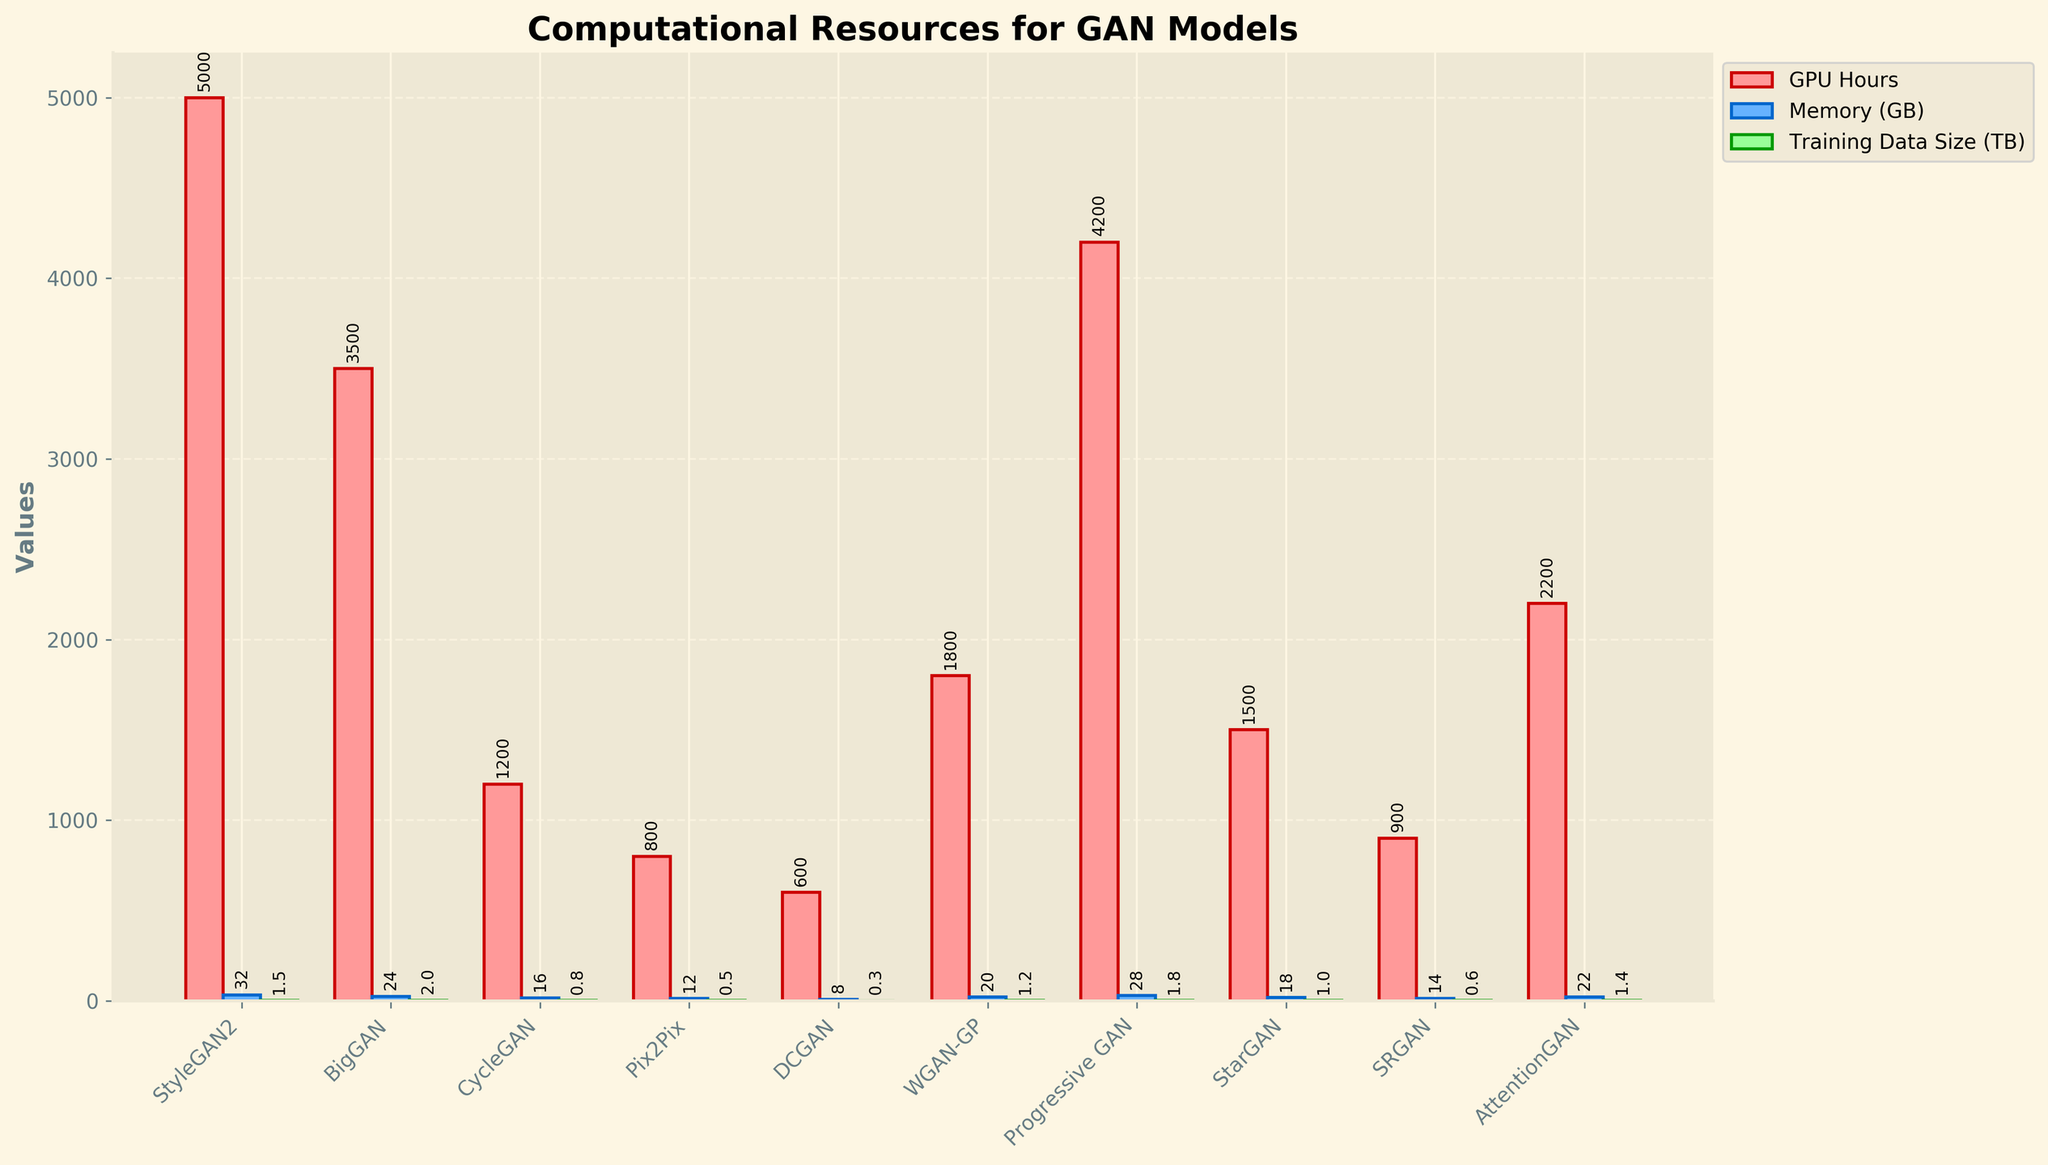Which GAN model requires the most GPU hours for training? The height of the red bar for each model indicates GPU hours. The tallest red bar corresponds to StyleGAN2.
Answer: StyleGAN2 Which GAN model uses the least memory (GB)? The height of the blue bar for each model indicates memory usage. The shortest blue bar corresponds to DCGAN.
Answer: DCGAN What is the total amount of training data size (TB) required for BigGAN and Progressive GAN combined? From the green bars, BigGAN uses 2.0 TB and Progressive GAN uses 1.8 TB. Adding these gives 2.0 + 1.8 = 3.8 TB.
Answer: 3.8 TB Between CycleGAN and AttentionGAN, which model uses more GPU hours, and by how much? Comparing the red bars, AttentionGAN (2200 hours) requires more GPU hours than CycleGAN (1200 hours). The difference is 2200 - 1200 = 1000 hours.
Answer: AttentionGAN by 1000 hours Which model has the highest training data size (TB), and what is its value? The tallest green bar corresponds to BigGAN with a training data size of 2.0 TB.
Answer: BigGAN, 2.0 TB What is the difference in memory usage (GB) between SRGAN and WGAN-GP? The blue bar for WGAN-GP is 20 GB and for SRGAN is 14 GB. The difference is 20 - 14 = 6 GB.
Answer: 6 GB Which model has a training data size (TB) equal to 1.5? The green bar for StyleGAN2 has a height corresponding to 1.5 TB.
Answer: StyleGAN2 What is the average number of GPU hours required for training Pix2Pix and StarGAN? The red bars show Pix2Pix uses 800 hours and StarGAN uses 1500 hours. The average is (800 + 1500) / 2 = 1150 hours.
Answer: 1150 hours How much more memory (GB) does Progressive GAN use compared to Pix2Pix? The blue bars show Progressive GAN uses 28 GB and Pix2Pix uses 12 GB. The difference is 28 - 12 = 16 GB.
Answer: 16 GB Among the models that require over 2000 GPU hours, which one uses the least training data size (TB)? Models with over 2000 GPU hours are StyleGAN2, Progressive GAN, and AttentionGAN. Among these, the green bar indicates AttentionGAN uses the least training data size with 1.4 TB.
Answer: AttentionGAN 